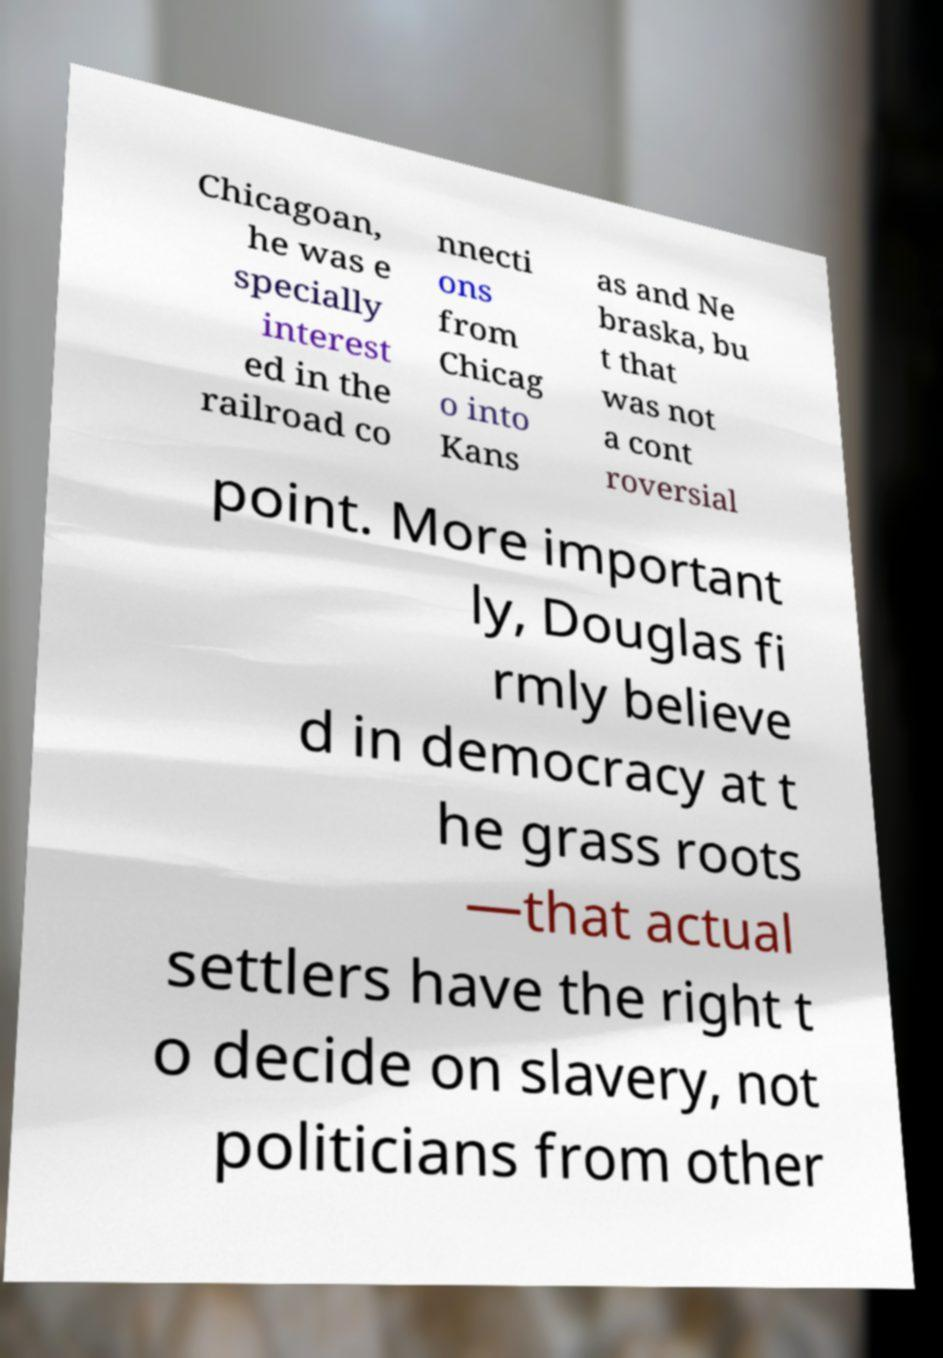Please identify and transcribe the text found in this image. Chicagoan, he was e specially interest ed in the railroad co nnecti ons from Chicag o into Kans as and Ne braska, bu t that was not a cont roversial point. More important ly, Douglas fi rmly believe d in democracy at t he grass roots —that actual settlers have the right t o decide on slavery, not politicians from other 